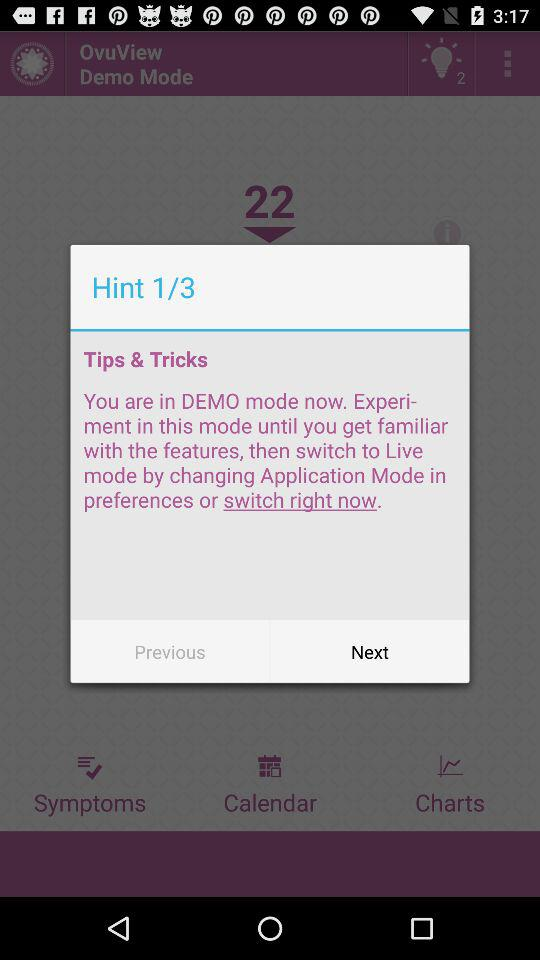What is the total number of hints? The total number of hints is 3. 